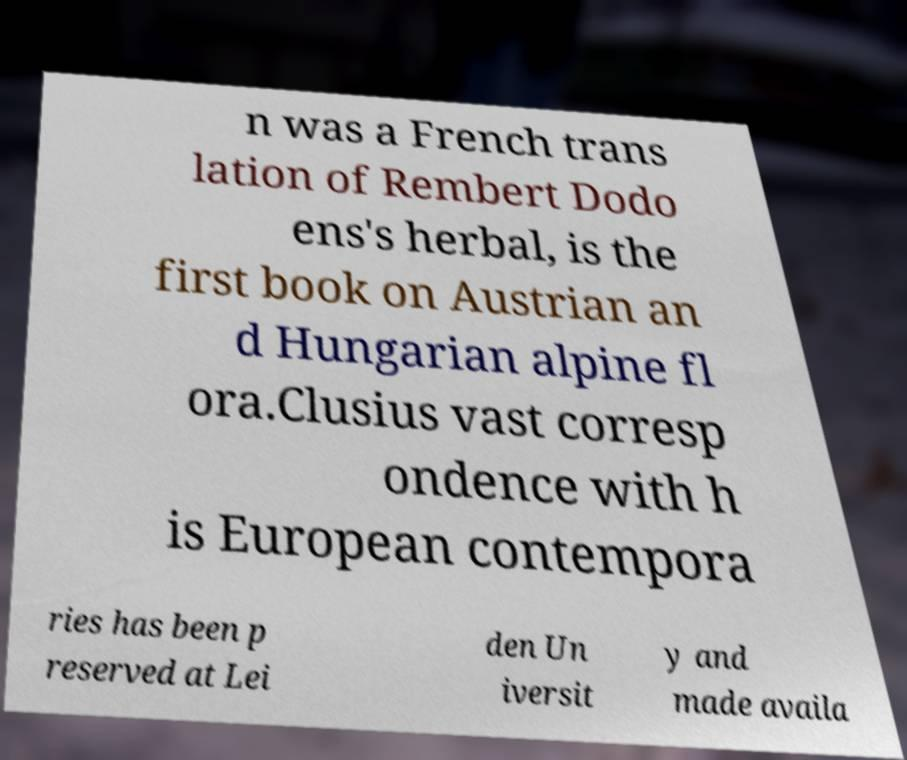I need the written content from this picture converted into text. Can you do that? n was a French trans lation of Rembert Dodo ens's herbal, is the first book on Austrian an d Hungarian alpine fl ora.Clusius vast corresp ondence with h is European contempora ries has been p reserved at Lei den Un iversit y and made availa 